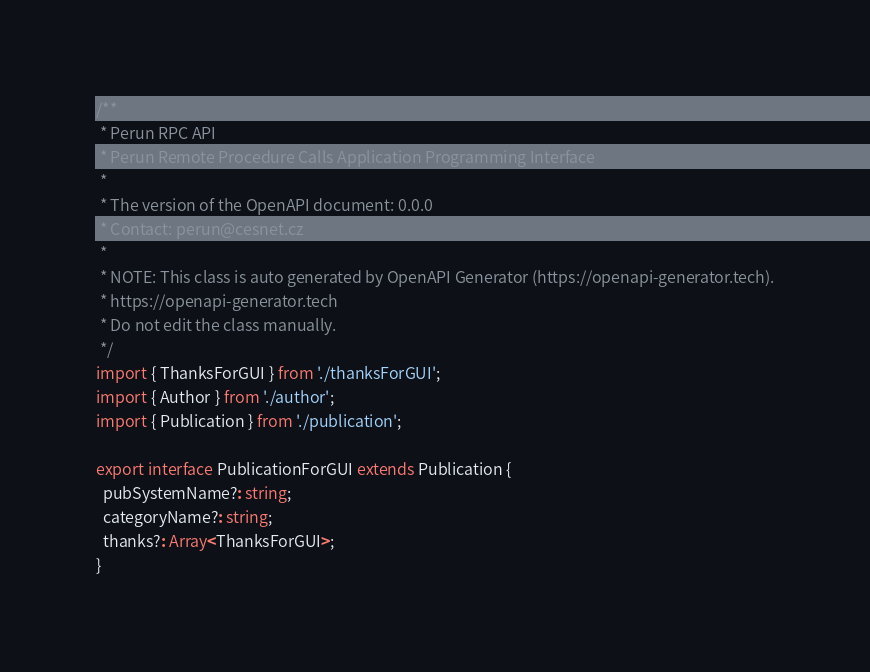<code> <loc_0><loc_0><loc_500><loc_500><_TypeScript_>/**
 * Perun RPC API
 * Perun Remote Procedure Calls Application Programming Interface
 *
 * The version of the OpenAPI document: 0.0.0
 * Contact: perun@cesnet.cz
 *
 * NOTE: This class is auto generated by OpenAPI Generator (https://openapi-generator.tech).
 * https://openapi-generator.tech
 * Do not edit the class manually.
 */
import { ThanksForGUI } from './thanksForGUI';
import { Author } from './author';
import { Publication } from './publication';

export interface PublicationForGUI extends Publication {
  pubSystemName?: string;
  categoryName?: string;
  thanks?: Array<ThanksForGUI>;
}
</code> 